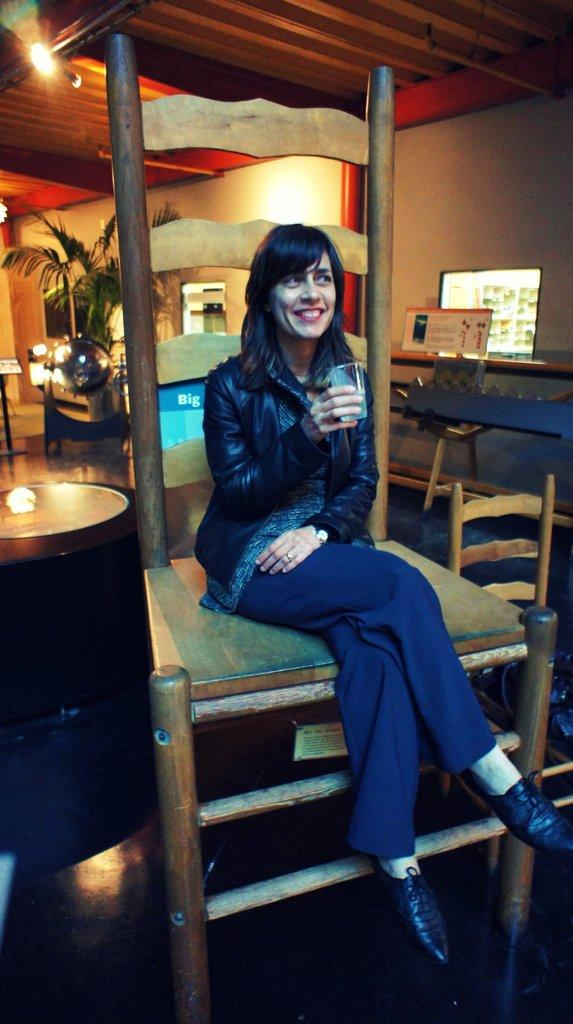What is the woman in the image doing? The woman is sitting on a chair in the image. What is the woman holding in the image? The woman is holding a glass in the image. What can be seen in the background of the image? There are plants visible in the image. What type of lighting is present in the image? There is a light in the image. What is located beside the chair in the image? There is a table beside the chair in the image. What is the woman wearing on her upper body in the image? The woman is wearing a black jacket in the image. What type of arch can be seen in the image? There is no arch present in the image. How many pets are visible in the image? There are no pets visible in the image. 